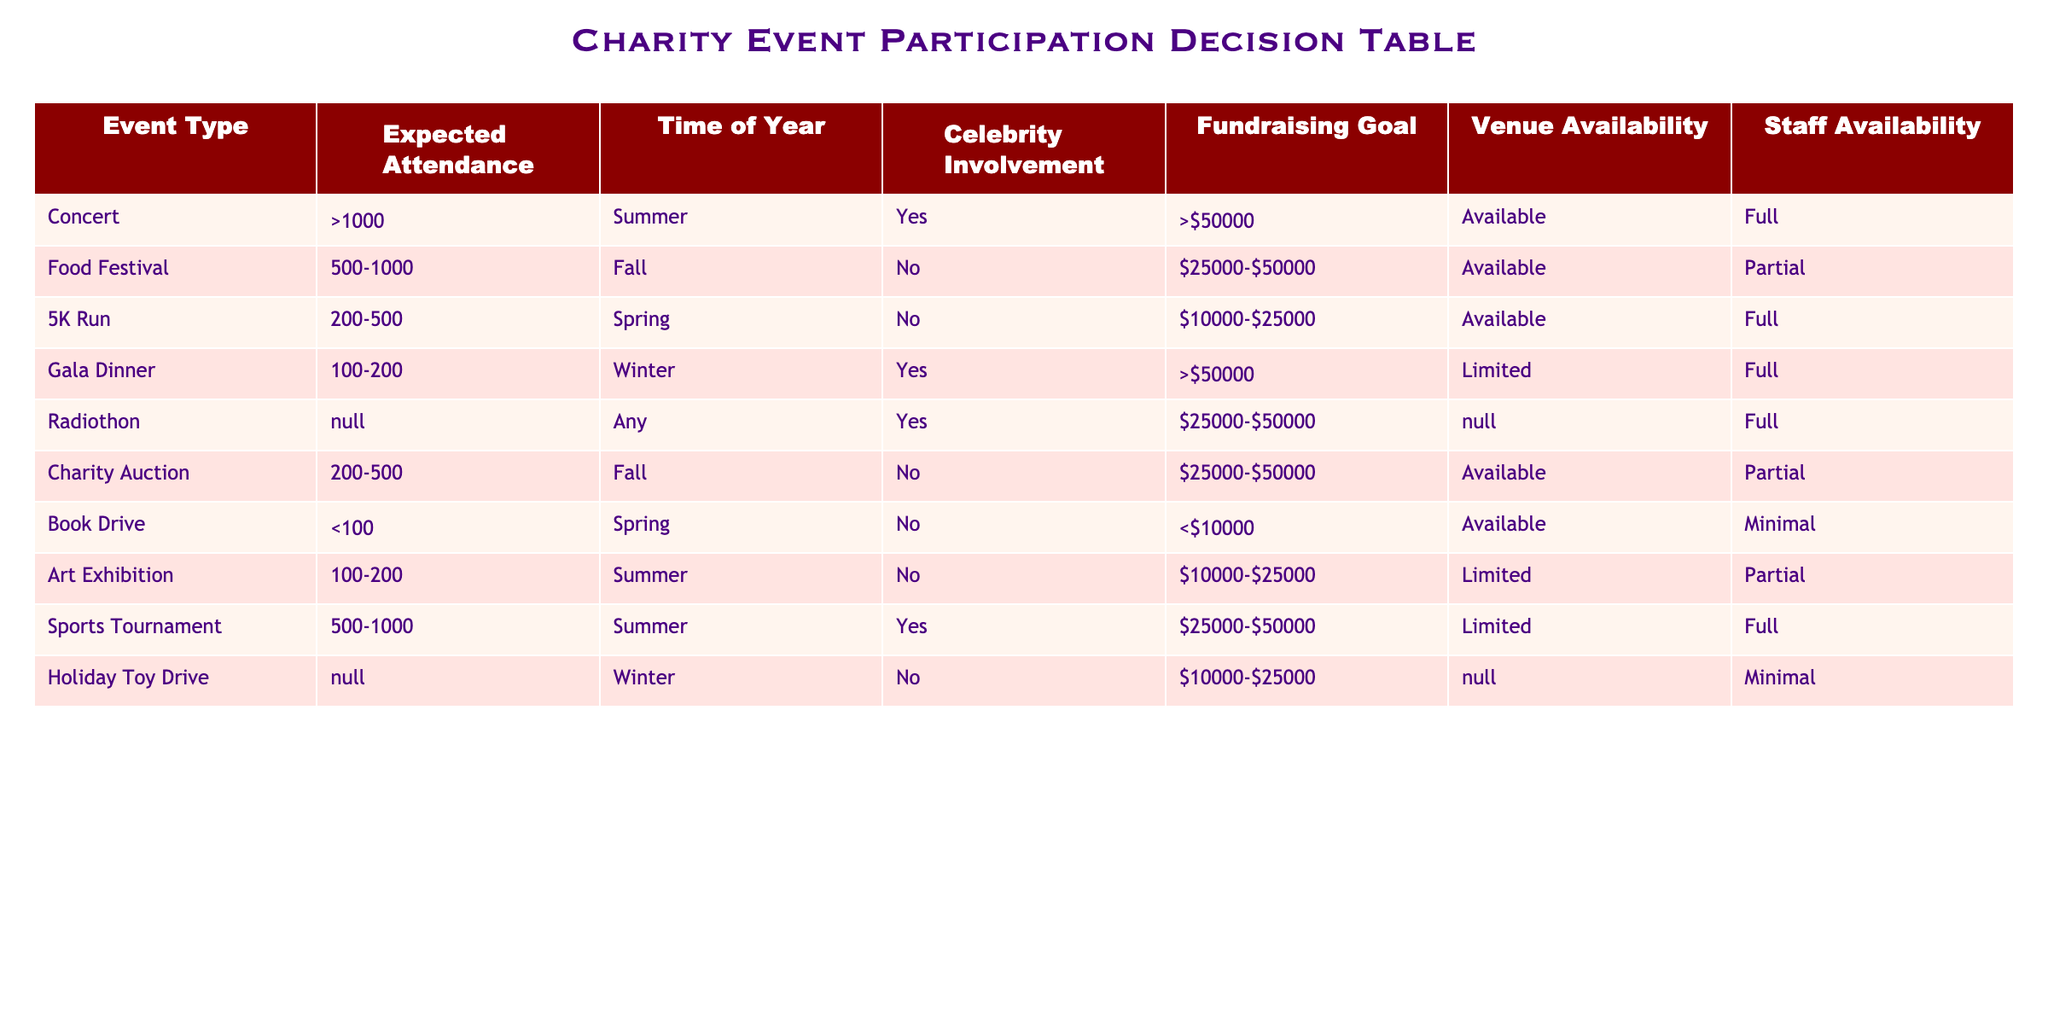What is the expected attendance for the Food Festival? According to the table, the expected attendance for the Food Festival is listed as 500-1000.
Answer: 500-1000 How many events have celebrity involvement? By reviewing the Celebrity Involvement column, the events listed as having celebrity involvement are the Concert, Gala Dinner, and Radiothon. Therefore, there are three events.
Answer: 3 What is the fundraising goal for the Holiday Toy Drive? The table states that the fundraising goal for the Holiday Toy Drive is between $10,000 and $25,000.
Answer: $10,000-$25,000 Is there venue availability for the 5K Run? In the Venue Availability column, it shows that the 5K Run is listed as Available. Therefore, there is venue availability.
Answer: Yes Which event has the highest expected attendance, and what is that number? Looking through the Expected Attendance column, the Concert has the highest expected attendance stated as greater than 1000.
Answer: >1000 What is the average expected attendance across all events? The attendance values are >1000, 500-1000, 200-500, 100-200, N/A, 200-500, <100, 100-200, 500-1000, and N/A. To calculate the average, we can only consider numeric values. Taking the midpoint of ranges where applicable, we take >1000 as an estimated 1001, 750 for 500-1000, 350 for 200-500, 150 for 100-200, and <100 as 99, we can calculate: (1001 + 750 + 350 + 150 + 0 + 350 + 99 + 150 + 750 + 0) / 8 = 292.875.
Answer: 292.875 Are all the events in the winter season limited in staff availability? In the Staff Availability column, both the Gala Dinner and Holiday Toy Drive are noted as Limited and Minimal respectively. Therefore, not all events in winter are limited in staff availability.
Answer: No What type of event has the lowest fundraising goal? By examining the Fundraising Goal column, the Book Drive is listed with a fundraising goal of less than $10,000, which is noted as the lowest amount in the table.
Answer: Book Drive Which season has the most events listed in the table? By reviewing the Time of Year column, counting each event by season, there are two events in both Fall and Summer, one in Spring, two in Winter, and one that can occur Any time. Summer and Fall both have the most events listed, with a total of two each.
Answer: Summer and Fall 